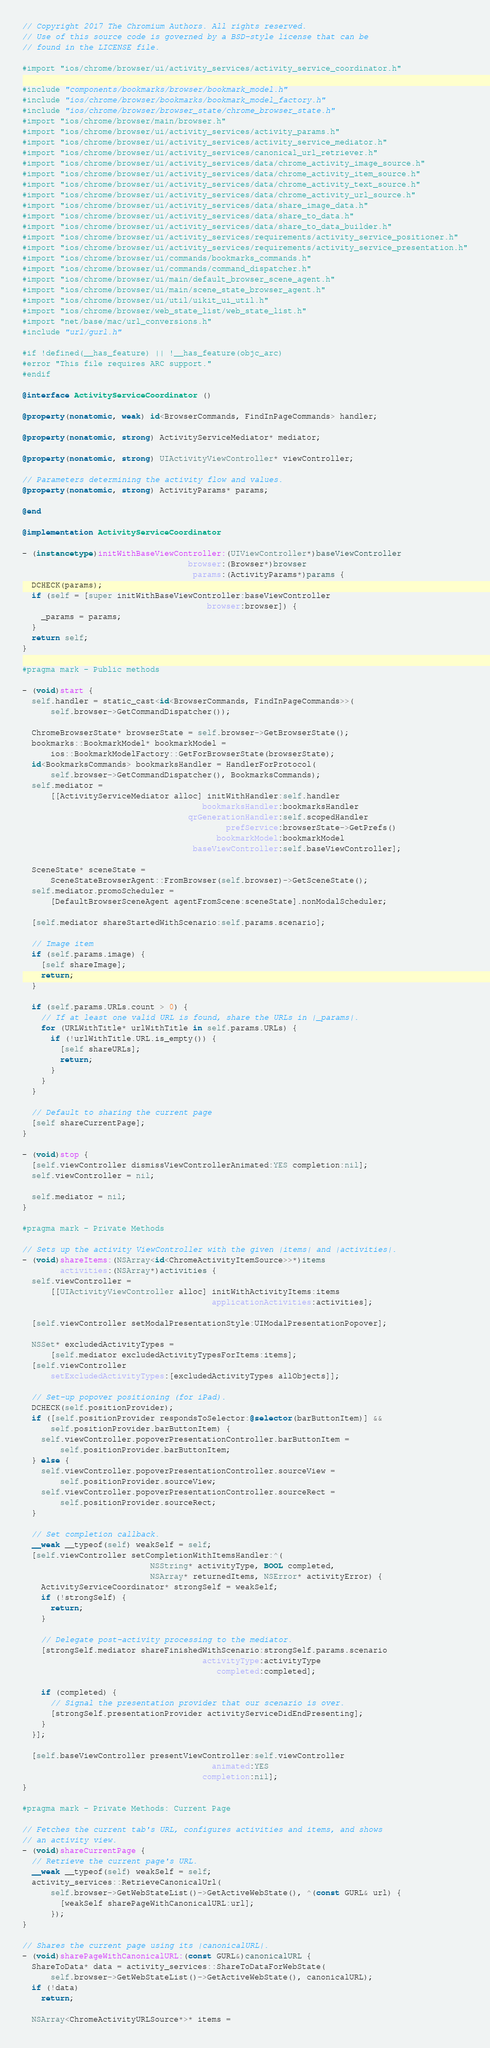Convert code to text. <code><loc_0><loc_0><loc_500><loc_500><_ObjectiveC_>// Copyright 2017 The Chromium Authors. All rights reserved.
// Use of this source code is governed by a BSD-style license that can be
// found in the LICENSE file.

#import "ios/chrome/browser/ui/activity_services/activity_service_coordinator.h"

#include "components/bookmarks/browser/bookmark_model.h"
#include "ios/chrome/browser/bookmarks/bookmark_model_factory.h"
#include "ios/chrome/browser/browser_state/chrome_browser_state.h"
#import "ios/chrome/browser/main/browser.h"
#import "ios/chrome/browser/ui/activity_services/activity_params.h"
#import "ios/chrome/browser/ui/activity_services/activity_service_mediator.h"
#import "ios/chrome/browser/ui/activity_services/canonical_url_retriever.h"
#import "ios/chrome/browser/ui/activity_services/data/chrome_activity_image_source.h"
#import "ios/chrome/browser/ui/activity_services/data/chrome_activity_item_source.h"
#import "ios/chrome/browser/ui/activity_services/data/chrome_activity_text_source.h"
#import "ios/chrome/browser/ui/activity_services/data/chrome_activity_url_source.h"
#import "ios/chrome/browser/ui/activity_services/data/share_image_data.h"
#import "ios/chrome/browser/ui/activity_services/data/share_to_data.h"
#import "ios/chrome/browser/ui/activity_services/data/share_to_data_builder.h"
#import "ios/chrome/browser/ui/activity_services/requirements/activity_service_positioner.h"
#import "ios/chrome/browser/ui/activity_services/requirements/activity_service_presentation.h"
#import "ios/chrome/browser/ui/commands/bookmarks_commands.h"
#import "ios/chrome/browser/ui/commands/command_dispatcher.h"
#import "ios/chrome/browser/ui/main/default_browser_scene_agent.h"
#import "ios/chrome/browser/ui/main/scene_state_browser_agent.h"
#import "ios/chrome/browser/ui/util/uikit_ui_util.h"
#import "ios/chrome/browser/web_state_list/web_state_list.h"
#import "net/base/mac/url_conversions.h"
#include "url/gurl.h"

#if !defined(__has_feature) || !__has_feature(objc_arc)
#error "This file requires ARC support."
#endif

@interface ActivityServiceCoordinator ()

@property(nonatomic, weak) id<BrowserCommands, FindInPageCommands> handler;

@property(nonatomic, strong) ActivityServiceMediator* mediator;

@property(nonatomic, strong) UIActivityViewController* viewController;

// Parameters determining the activity flow and values.
@property(nonatomic, strong) ActivityParams* params;

@end

@implementation ActivityServiceCoordinator

- (instancetype)initWithBaseViewController:(UIViewController*)baseViewController
                                   browser:(Browser*)browser
                                    params:(ActivityParams*)params {
  DCHECK(params);
  if (self = [super initWithBaseViewController:baseViewController
                                       browser:browser]) {
    _params = params;
  }
  return self;
}

#pragma mark - Public methods

- (void)start {
  self.handler = static_cast<id<BrowserCommands, FindInPageCommands>>(
      self.browser->GetCommandDispatcher());

  ChromeBrowserState* browserState = self.browser->GetBrowserState();
  bookmarks::BookmarkModel* bookmarkModel =
      ios::BookmarkModelFactory::GetForBrowserState(browserState);
  id<BookmarksCommands> bookmarksHandler = HandlerForProtocol(
      self.browser->GetCommandDispatcher(), BookmarksCommands);
  self.mediator =
      [[ActivityServiceMediator alloc] initWithHandler:self.handler
                                      bookmarksHandler:bookmarksHandler
                                   qrGenerationHandler:self.scopedHandler
                                           prefService:browserState->GetPrefs()
                                         bookmarkModel:bookmarkModel
                                    baseViewController:self.baseViewController];

  SceneState* sceneState =
      SceneStateBrowserAgent::FromBrowser(self.browser)->GetSceneState();
  self.mediator.promoScheduler =
      [DefaultBrowserSceneAgent agentFromScene:sceneState].nonModalScheduler;

  [self.mediator shareStartedWithScenario:self.params.scenario];

  // Image item
  if (self.params.image) {
    [self shareImage];
    return;
  }

  if (self.params.URLs.count > 0) {
    // If at least one valid URL is found, share the URLs in |_params|.
    for (URLWithTitle* urlWithTitle in self.params.URLs) {
      if (!urlWithTitle.URL.is_empty()) {
        [self shareURLs];
        return;
      }
    }
  }

  // Default to sharing the current page
  [self shareCurrentPage];
}

- (void)stop {
  [self.viewController dismissViewControllerAnimated:YES completion:nil];
  self.viewController = nil;

  self.mediator = nil;
}

#pragma mark - Private Methods

// Sets up the activity ViewController with the given |items| and |activities|.
- (void)shareItems:(NSArray<id<ChromeActivityItemSource>>*)items
        activities:(NSArray*)activities {
  self.viewController =
      [[UIActivityViewController alloc] initWithActivityItems:items
                                        applicationActivities:activities];

  [self.viewController setModalPresentationStyle:UIModalPresentationPopover];

  NSSet* excludedActivityTypes =
      [self.mediator excludedActivityTypesForItems:items];
  [self.viewController
      setExcludedActivityTypes:[excludedActivityTypes allObjects]];

  // Set-up popover positioning (for iPad).
  DCHECK(self.positionProvider);
  if ([self.positionProvider respondsToSelector:@selector(barButtonItem)] &&
      self.positionProvider.barButtonItem) {
    self.viewController.popoverPresentationController.barButtonItem =
        self.positionProvider.barButtonItem;
  } else {
    self.viewController.popoverPresentationController.sourceView =
        self.positionProvider.sourceView;
    self.viewController.popoverPresentationController.sourceRect =
        self.positionProvider.sourceRect;
  }

  // Set completion callback.
  __weak __typeof(self) weakSelf = self;
  [self.viewController setCompletionWithItemsHandler:^(
                           NSString* activityType, BOOL completed,
                           NSArray* returnedItems, NSError* activityError) {
    ActivityServiceCoordinator* strongSelf = weakSelf;
    if (!strongSelf) {
      return;
    }

    // Delegate post-activity processing to the mediator.
    [strongSelf.mediator shareFinishedWithScenario:strongSelf.params.scenario
                                      activityType:activityType
                                         completed:completed];

    if (completed) {
      // Signal the presentation provider that our scenario is over.
      [strongSelf.presentationProvider activityServiceDidEndPresenting];
    }
  }];

  [self.baseViewController presentViewController:self.viewController
                                        animated:YES
                                      completion:nil];
}

#pragma mark - Private Methods: Current Page

// Fetches the current tab's URL, configures activities and items, and shows
// an activity view.
- (void)shareCurrentPage {
  // Retrieve the current page's URL.
  __weak __typeof(self) weakSelf = self;
  activity_services::RetrieveCanonicalUrl(
      self.browser->GetWebStateList()->GetActiveWebState(), ^(const GURL& url) {
        [weakSelf sharePageWithCanonicalURL:url];
      });
}

// Shares the current page using its |canonicalURL|.
- (void)sharePageWithCanonicalURL:(const GURL&)canonicalURL {
  ShareToData* data = activity_services::ShareToDataForWebState(
      self.browser->GetWebStateList()->GetActiveWebState(), canonicalURL);
  if (!data)
    return;

  NSArray<ChromeActivityURLSource*>* items =</code> 